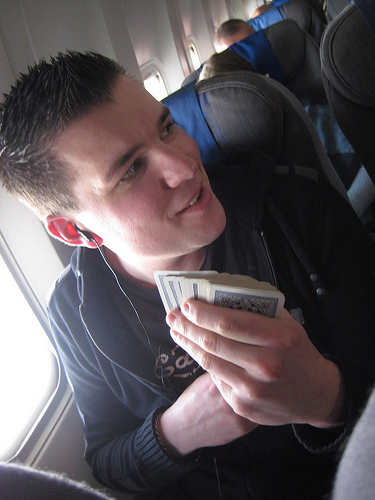<image>
Is there a seat behind the man? Yes. From this viewpoint, the seat is positioned behind the man, with the man partially or fully occluding the seat. Is the man in the sky? Yes. The man is contained within or inside the sky, showing a containment relationship. 